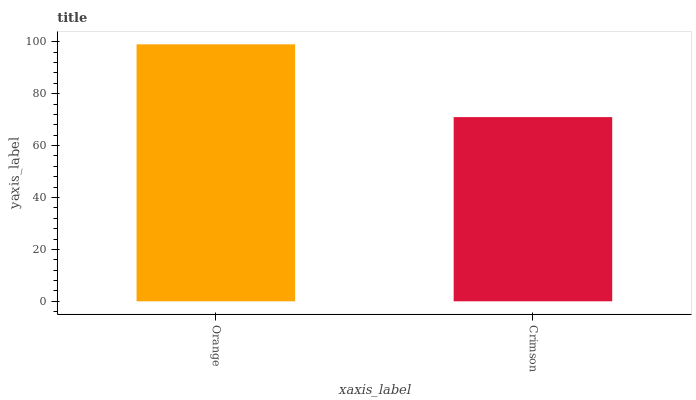Is Crimson the minimum?
Answer yes or no. Yes. Is Orange the maximum?
Answer yes or no. Yes. Is Crimson the maximum?
Answer yes or no. No. Is Orange greater than Crimson?
Answer yes or no. Yes. Is Crimson less than Orange?
Answer yes or no. Yes. Is Crimson greater than Orange?
Answer yes or no. No. Is Orange less than Crimson?
Answer yes or no. No. Is Orange the high median?
Answer yes or no. Yes. Is Crimson the low median?
Answer yes or no. Yes. Is Crimson the high median?
Answer yes or no. No. Is Orange the low median?
Answer yes or no. No. 